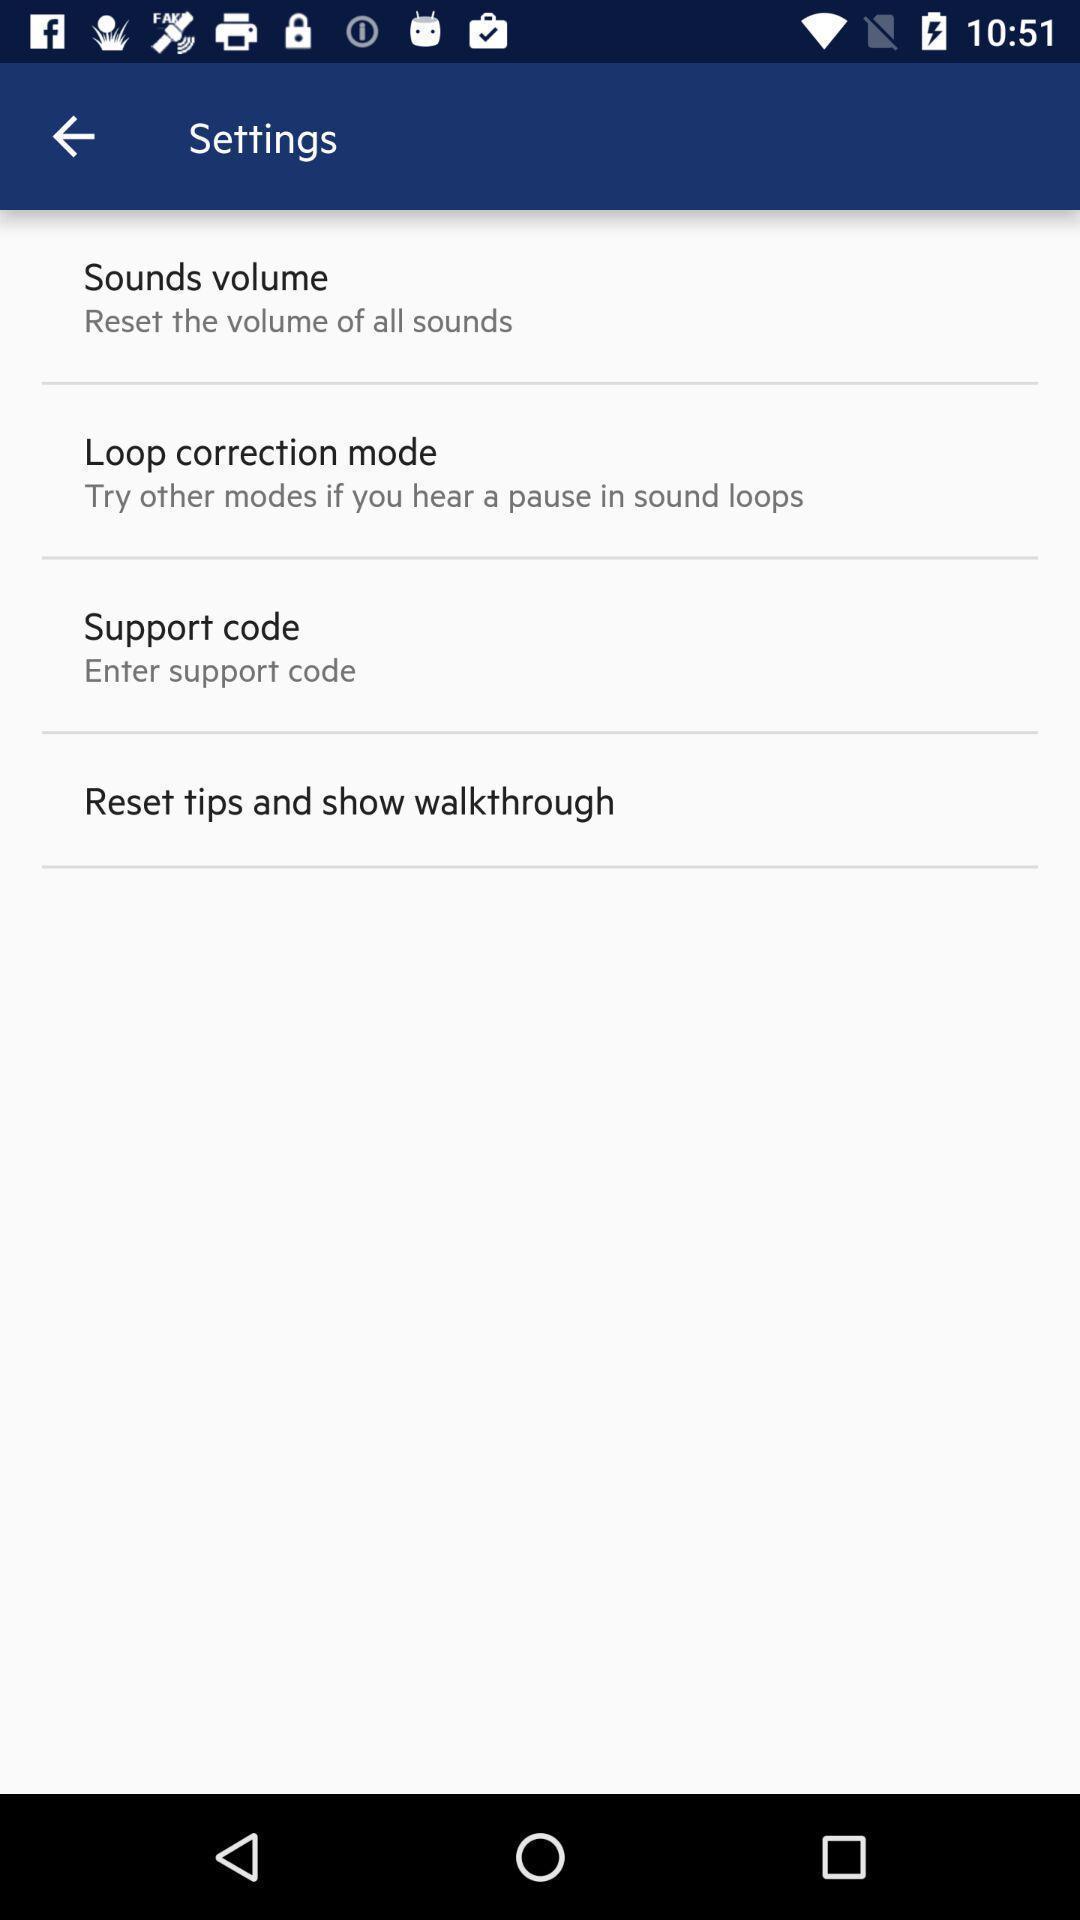What can you discern from this picture? Settings page. 